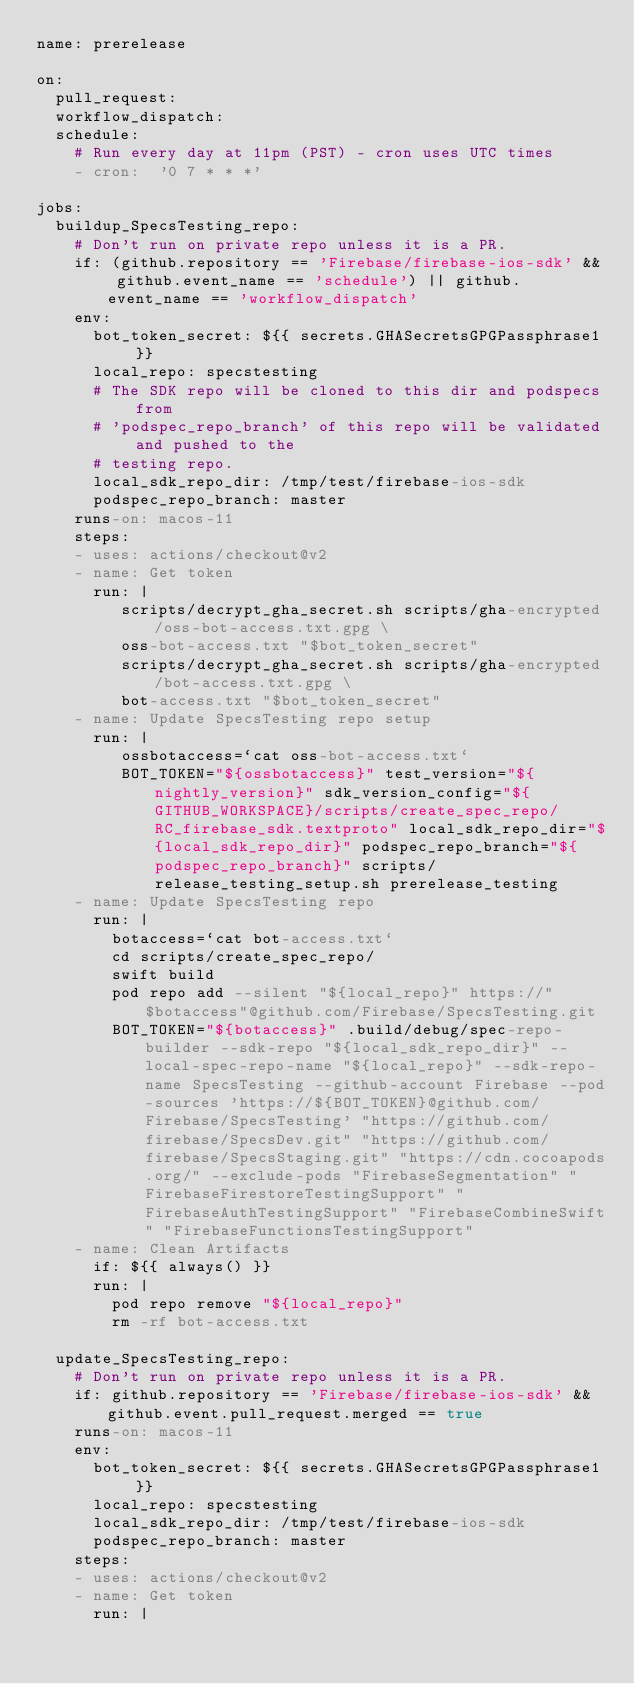Convert code to text. <code><loc_0><loc_0><loc_500><loc_500><_YAML_>name: prerelease

on:
  pull_request:
  workflow_dispatch:
  schedule:
    # Run every day at 11pm (PST) - cron uses UTC times
    - cron:  '0 7 * * *'

jobs:
  buildup_SpecsTesting_repo:
    # Don't run on private repo unless it is a PR.
    if: (github.repository == 'Firebase/firebase-ios-sdk' && github.event_name == 'schedule') || github.event_name == 'workflow_dispatch'
    env:
      bot_token_secret: ${{ secrets.GHASecretsGPGPassphrase1 }}
      local_repo: specstesting
      # The SDK repo will be cloned to this dir and podspecs from
      # 'podspec_repo_branch' of this repo will be validated and pushed to the
      # testing repo.
      local_sdk_repo_dir: /tmp/test/firebase-ios-sdk
      podspec_repo_branch: master
    runs-on: macos-11
    steps:
    - uses: actions/checkout@v2
    - name: Get token
      run: |
         scripts/decrypt_gha_secret.sh scripts/gha-encrypted/oss-bot-access.txt.gpg \
         oss-bot-access.txt "$bot_token_secret"
         scripts/decrypt_gha_secret.sh scripts/gha-encrypted/bot-access.txt.gpg \
         bot-access.txt "$bot_token_secret"
    - name: Update SpecsTesting repo setup
      run: |
         ossbotaccess=`cat oss-bot-access.txt`
         BOT_TOKEN="${ossbotaccess}" test_version="${nightly_version}" sdk_version_config="${GITHUB_WORKSPACE}/scripts/create_spec_repo/RC_firebase_sdk.textproto" local_sdk_repo_dir="${local_sdk_repo_dir}" podspec_repo_branch="${podspec_repo_branch}" scripts/release_testing_setup.sh prerelease_testing
    - name: Update SpecsTesting repo
      run: |
        botaccess=`cat bot-access.txt`
        cd scripts/create_spec_repo/
        swift build
        pod repo add --silent "${local_repo}" https://"$botaccess"@github.com/Firebase/SpecsTesting.git
        BOT_TOKEN="${botaccess}" .build/debug/spec-repo-builder --sdk-repo "${local_sdk_repo_dir}" --local-spec-repo-name "${local_repo}" --sdk-repo-name SpecsTesting --github-account Firebase --pod-sources 'https://${BOT_TOKEN}@github.com/Firebase/SpecsTesting' "https://github.com/firebase/SpecsDev.git" "https://github.com/firebase/SpecsStaging.git" "https://cdn.cocoapods.org/" --exclude-pods "FirebaseSegmentation" "FirebaseFirestoreTestingSupport" "FirebaseAuthTestingSupport" "FirebaseCombineSwift" "FirebaseFunctionsTestingSupport"
    - name: Clean Artifacts
      if: ${{ always() }}
      run: |
        pod repo remove "${local_repo}"
        rm -rf bot-access.txt

  update_SpecsTesting_repo:
    # Don't run on private repo unless it is a PR.
    if: github.repository == 'Firebase/firebase-ios-sdk' && github.event.pull_request.merged == true
    runs-on: macos-11
    env:
      bot_token_secret: ${{ secrets.GHASecretsGPGPassphrase1 }}
      local_repo: specstesting
      local_sdk_repo_dir: /tmp/test/firebase-ios-sdk
      podspec_repo_branch: master
    steps:
    - uses: actions/checkout@v2
    - name: Get token
      run: |</code> 